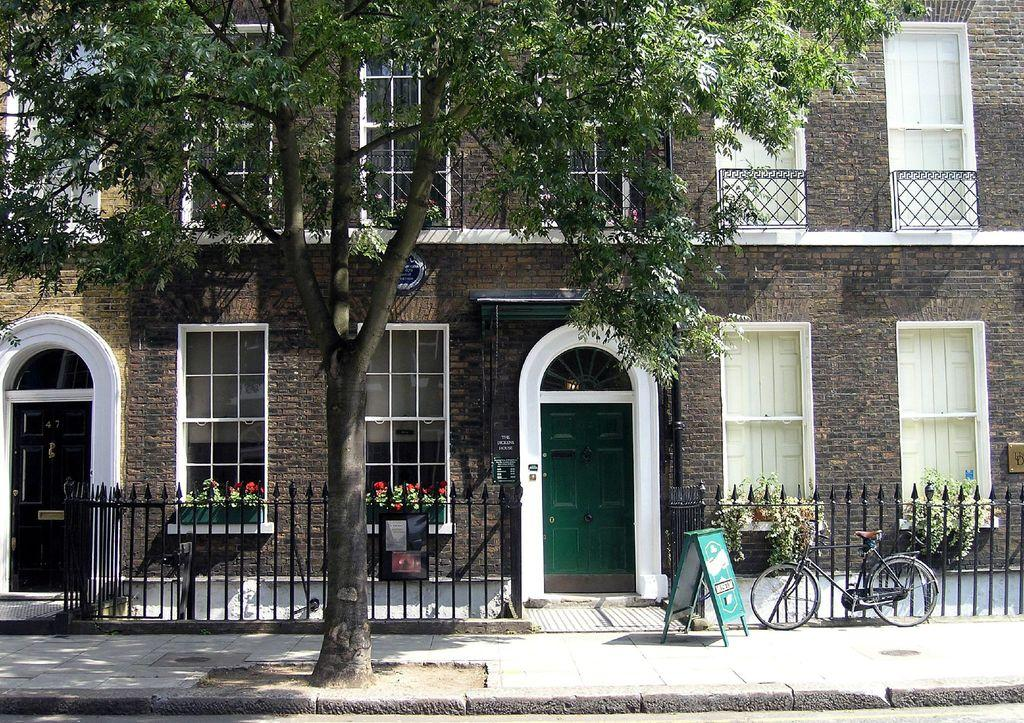What type of structure is visible in the image? There is a building in the image. What features can be seen on the building? The building has windows and doors. What type of vegetation is present in the image? There is a tree in the image. What mode of transportation can be seen in the image? There is a bicycle in the image. Can you tell me how many quinces are hanging from the tree in the image? There are no quinces present in the image; it features a tree without any visible fruit. What type of creature is shown interacting with the bicycle in the image? There is no creature shown interacting with the bicycle in the image; only the building, tree, and bicycle are present. 